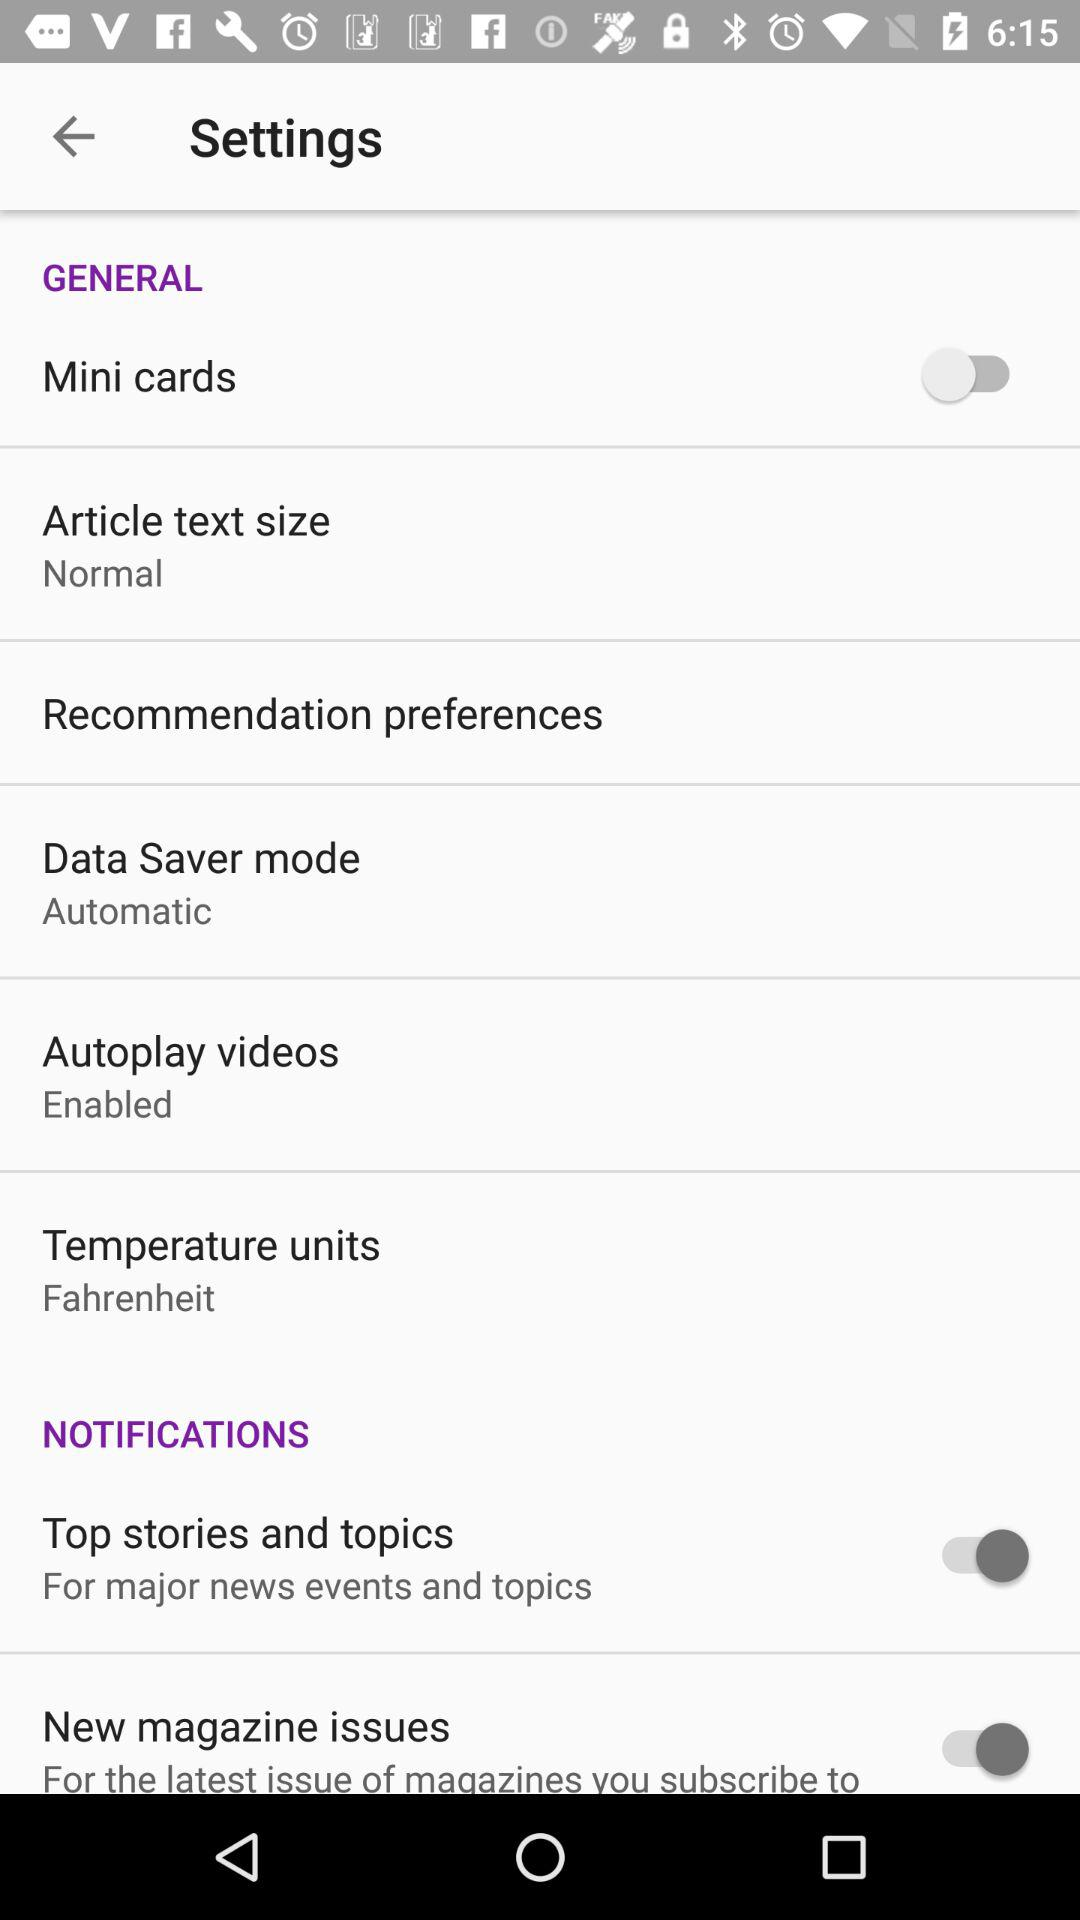How many of the items in the Notifications section have a switch?
Answer the question using a single word or phrase. 2 